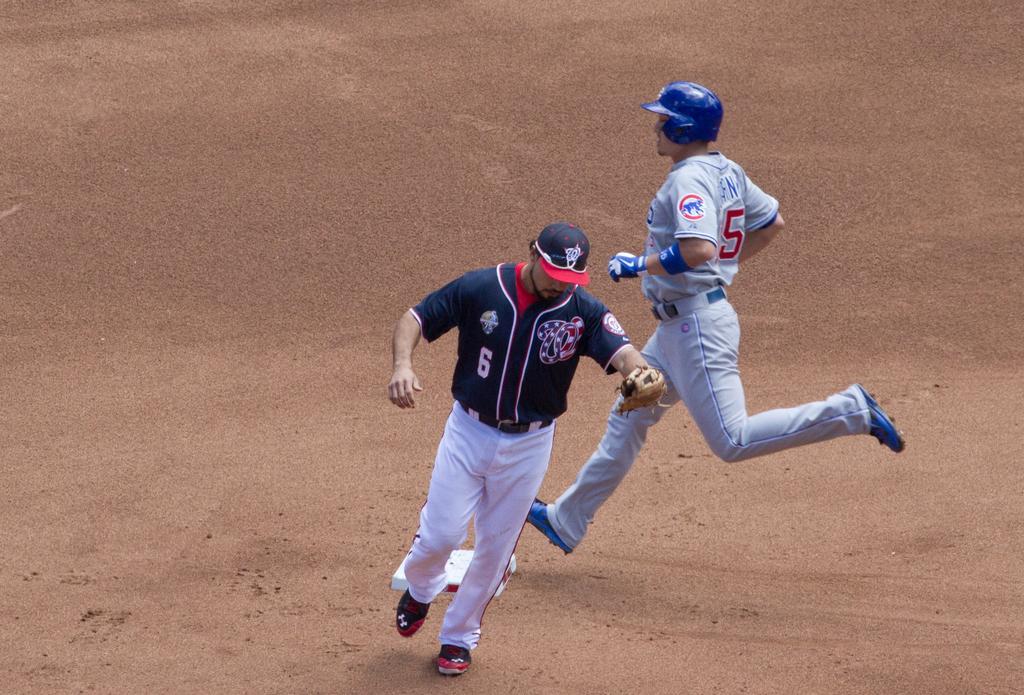In one or two sentences, can you explain what this image depicts? In this image I can see few people are wearing different color dresses. I can see the sand. 